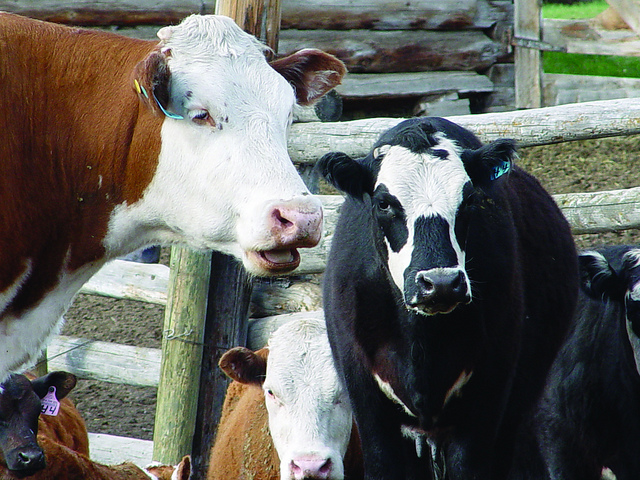Can you tell which breed of cows is visible in the image? In the image, we can see cows with distinctive markings and colorations. While I cannot physically analyze the image to provide a definitive answer, common dairy breeds include Holstein, known for their black and white patterns, and Jerseys, which tend to be smaller with a light brown coat. For precise identification, specific knowledge about the cattle breed characteristics is necessary. 